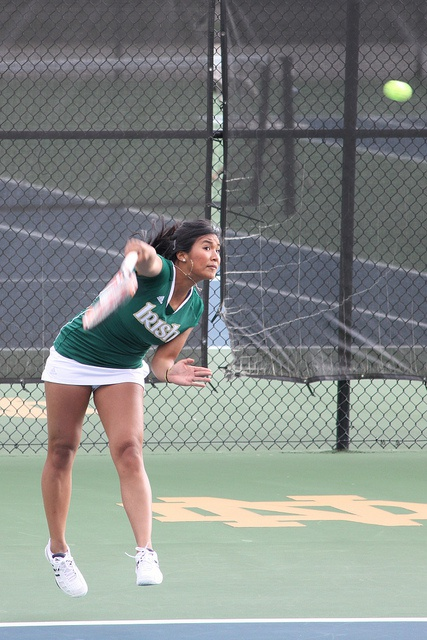Describe the objects in this image and their specific colors. I can see people in gray, brown, lavender, black, and lightpink tones, tennis racket in gray, lavender, darkgray, and lightpink tones, and sports ball in gray, khaki, lightyellow, and lightgreen tones in this image. 